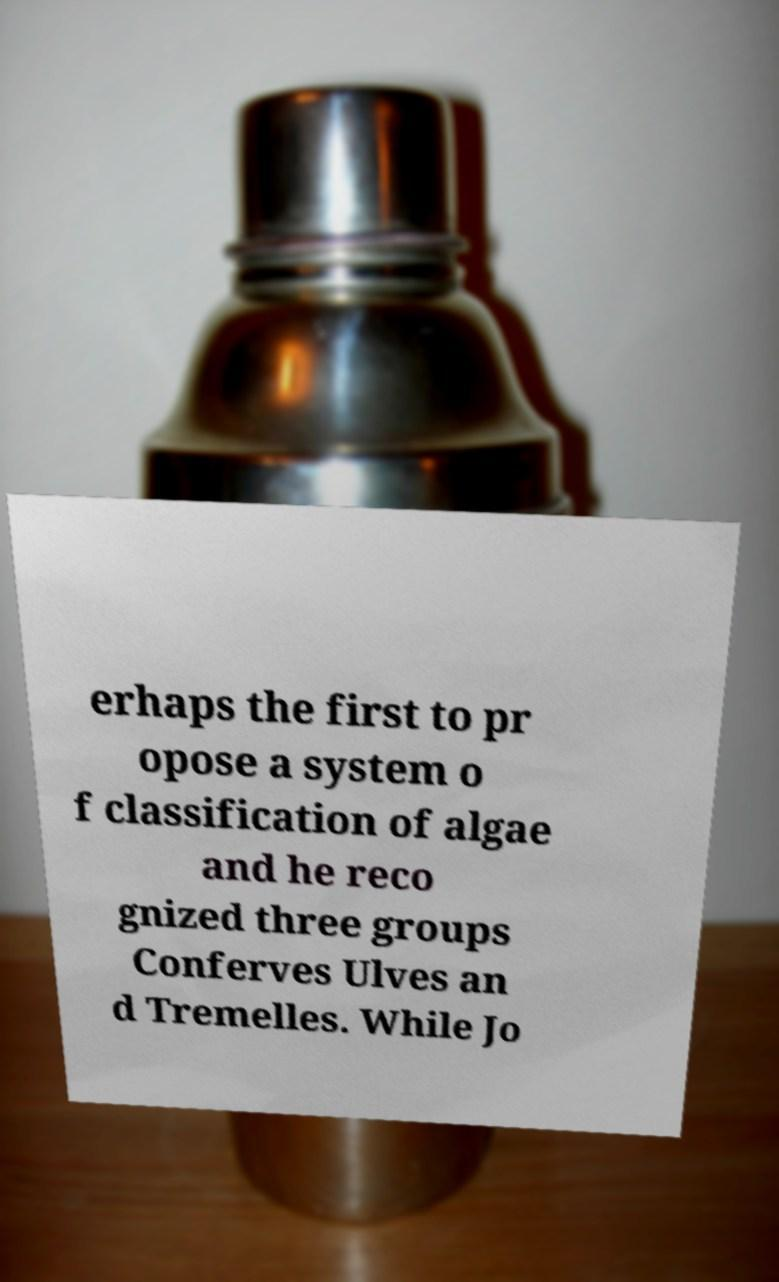I need the written content from this picture converted into text. Can you do that? erhaps the first to pr opose a system o f classification of algae and he reco gnized three groups Conferves Ulves an d Tremelles. While Jo 